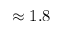Convert formula to latex. <formula><loc_0><loc_0><loc_500><loc_500>\approx 1 . 8</formula> 